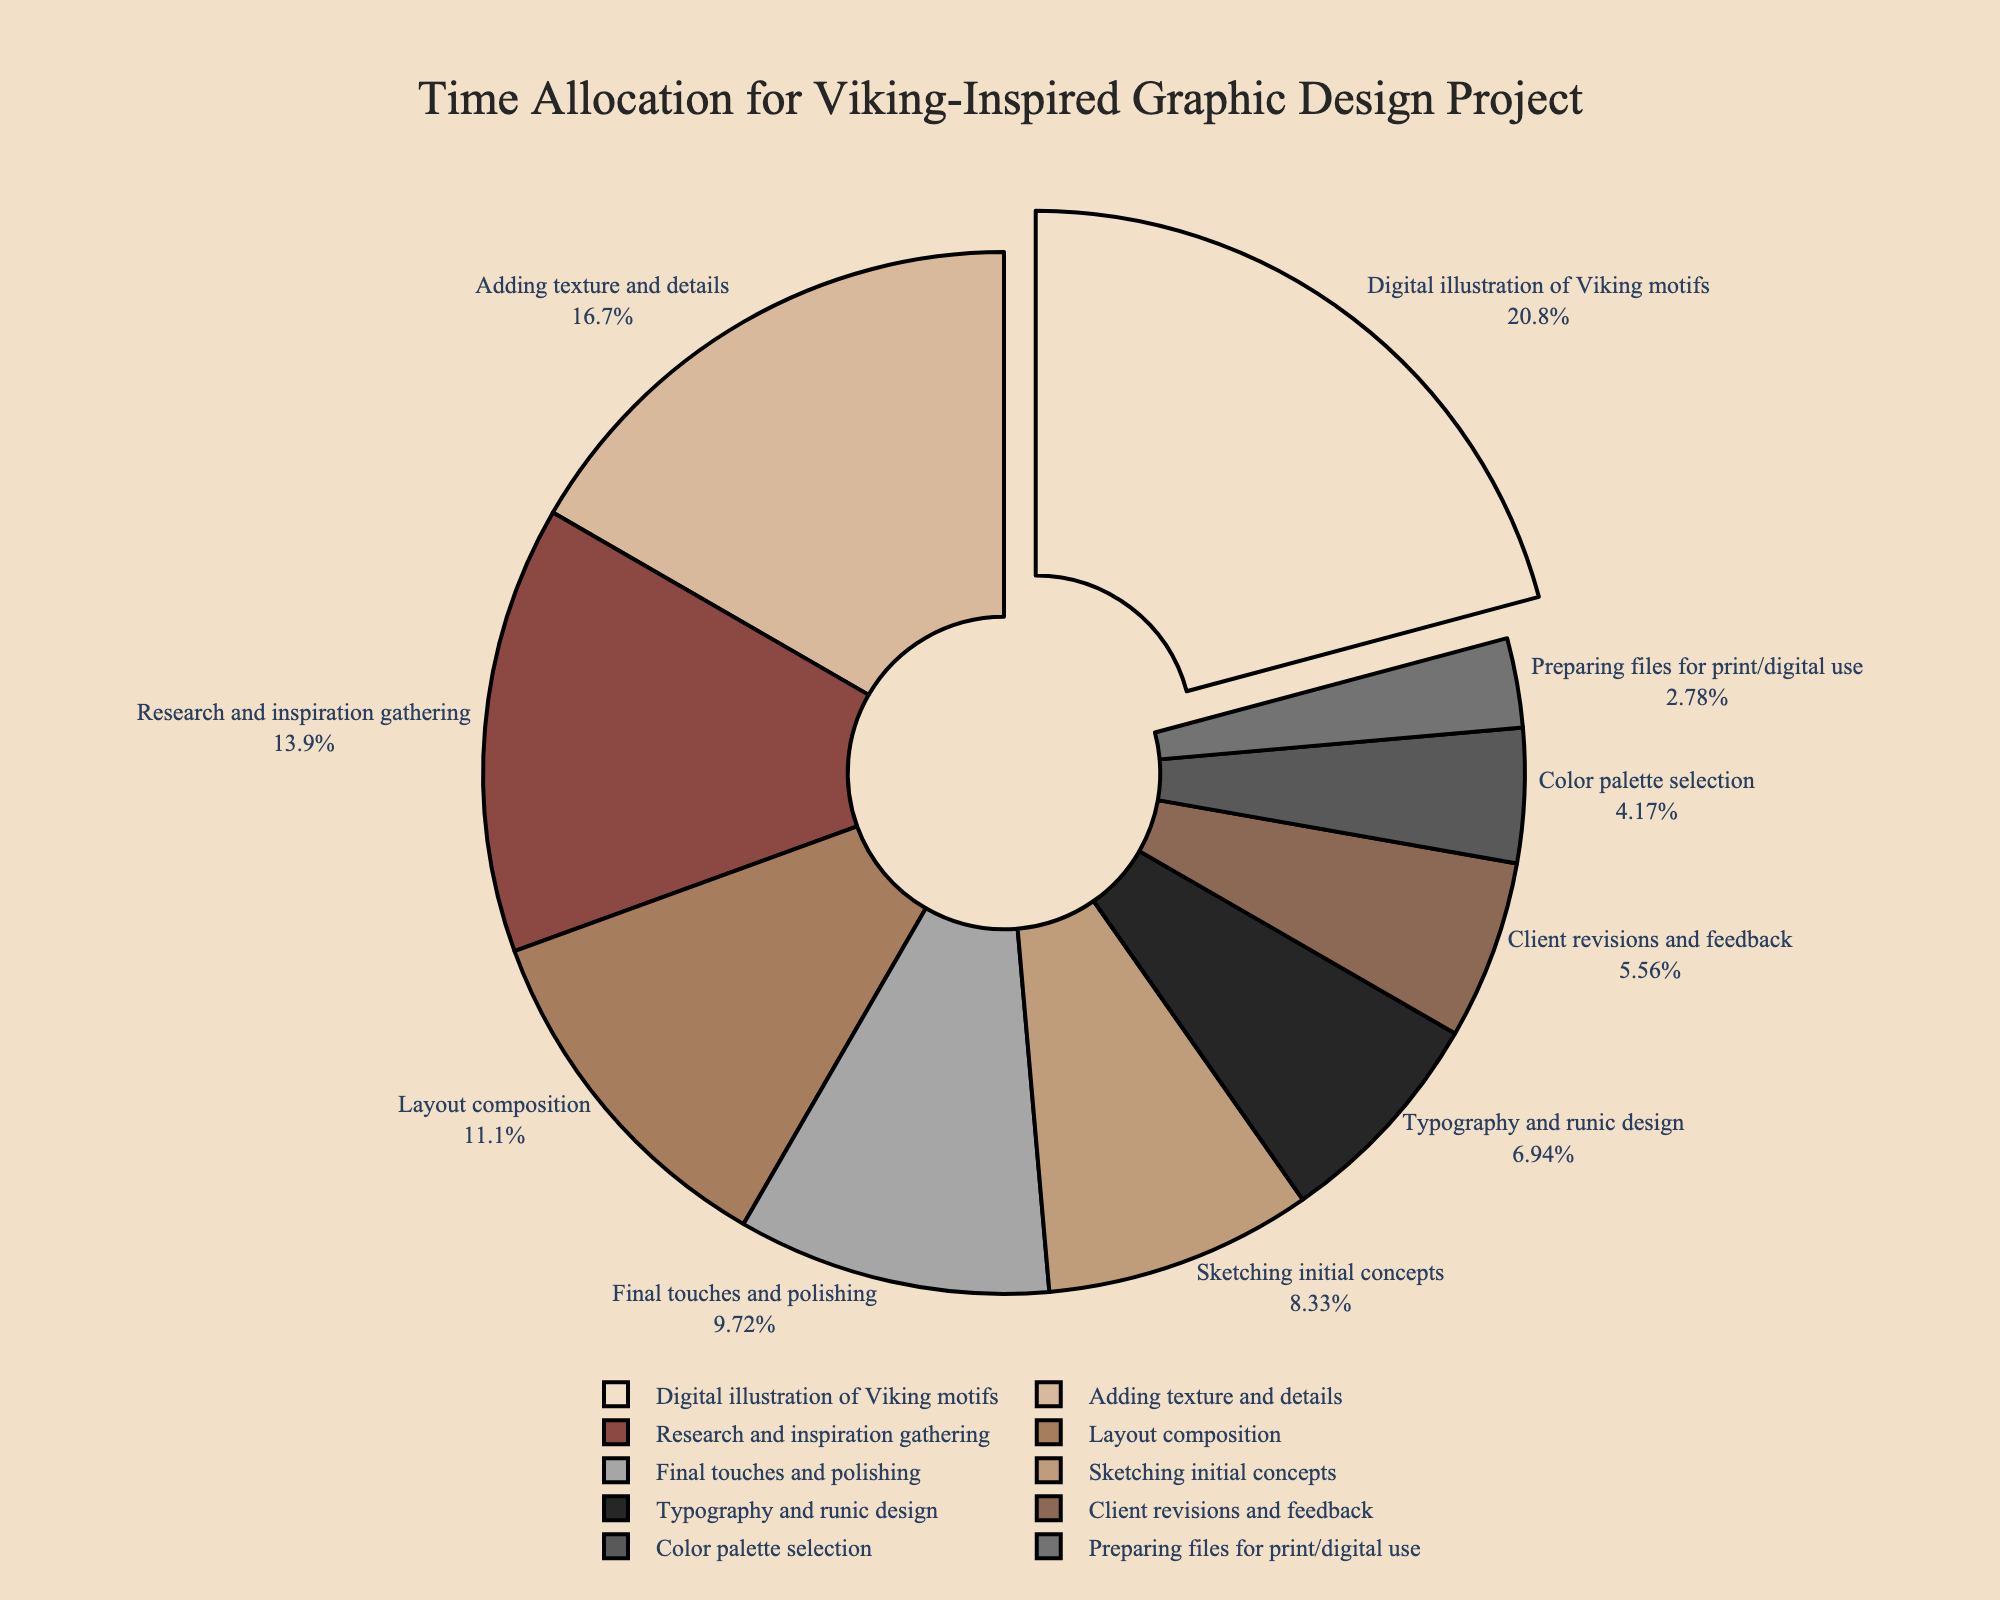What is the largest time allocation stage? The segment of the pie chart that is slightly pulled out indicates the stage with the largest time allocation. It represents the "Digital illustration of Viking motifs" stage.
Answer: Digital illustration of Viking motifs Which stage takes up the least amount of time? The figure indicates the smallest segment of the pie chart represents the stage "Preparing files for print/digital use" with the least time allocation.
Answer: Preparing files for print/digital use What percentage of time is spent on "Adding texture and details"? The pie chart shows each segment with its corresponding percentage. The "Adding texture and details" segment makes up 20% of the total time.
Answer: 20% Compare the time spent on "Research and inspiration gathering" with "Client revisions and feedback". Which one is higher, and by how much? By looking at the segments, "Research and inspiration gathering" (10 hours) is larger than "Client revisions and feedback" (4 hours). The difference is 6 hours.
Answer: Research and inspiration gathering by 6 hours What is the combined percentage of time spent on "Typography and runic design" and "Layout composition"? The percentages of "Typography and runic design" (8.33%) and "Layout composition" (13.33%) combine to 21.66%.
Answer: 21.66% How does the time spent on "Sketching initial concepts" compare to the time spent on "Final touches and polishing"? The segment sizes indicate that "Sketching initial concepts" (6 hours) takes less time compared to "Final touches and polishing" (7 hours).
Answer: Final touches and polishing is 1 hour more What is the average time allocated per stage? Sum the total hours (72) and divide by the number of stages (10). The average time allocation per stage is 7.2 hours.
Answer: 7.2 hours Which stage uses the color red? In the pie chart, the red-colored segment corresponds to "Research and inspiration gathering".
Answer: Research and inspiration gathering How much more time is spent on "Digital illustration of Viking motifs" than "Color palette selection"? The figure indicates that 15 hours are spent on "Digital illustration of Viking motifs" while 3 hours on "Color palette selection". The difference is 12 hours.
Answer: 12 hours What percentage of the project's time is spent during the initial design phases (first two stages)? The sum of the hours for the initial design phases: "Research and inspiration gathering" (10 hours) and "Sketching initial concepts" (6 hours) is 16. The percentage is (16/72) * 100 which equals approximately 22.22%.
Answer: 22.22% 